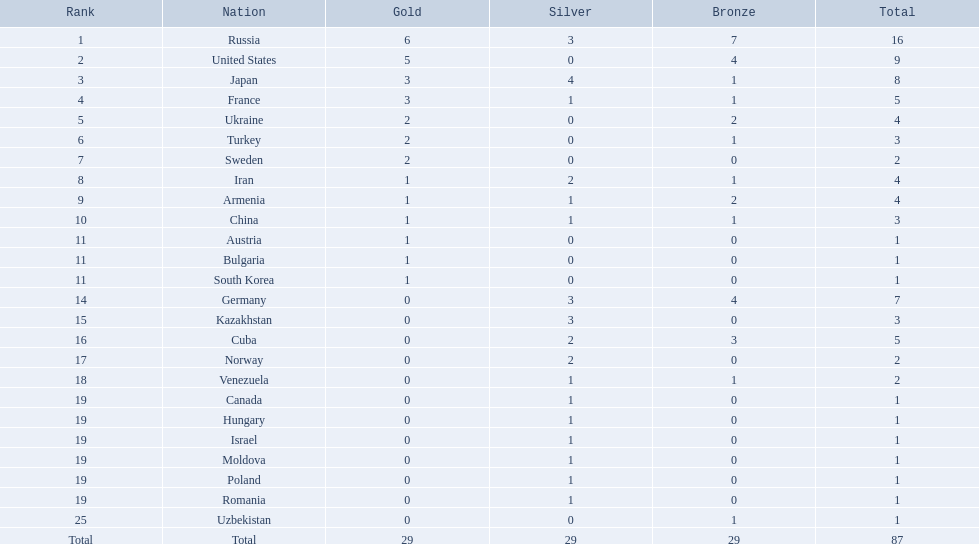What was iran's ranking? 8. What was germany's ranking? 14. Between iran and germany, which was not in the top 10? Germany. In how many nations were there competitors? Israel. What was russia's total medal count? 16. Which country managed to win just one medal? Uzbekistan. 